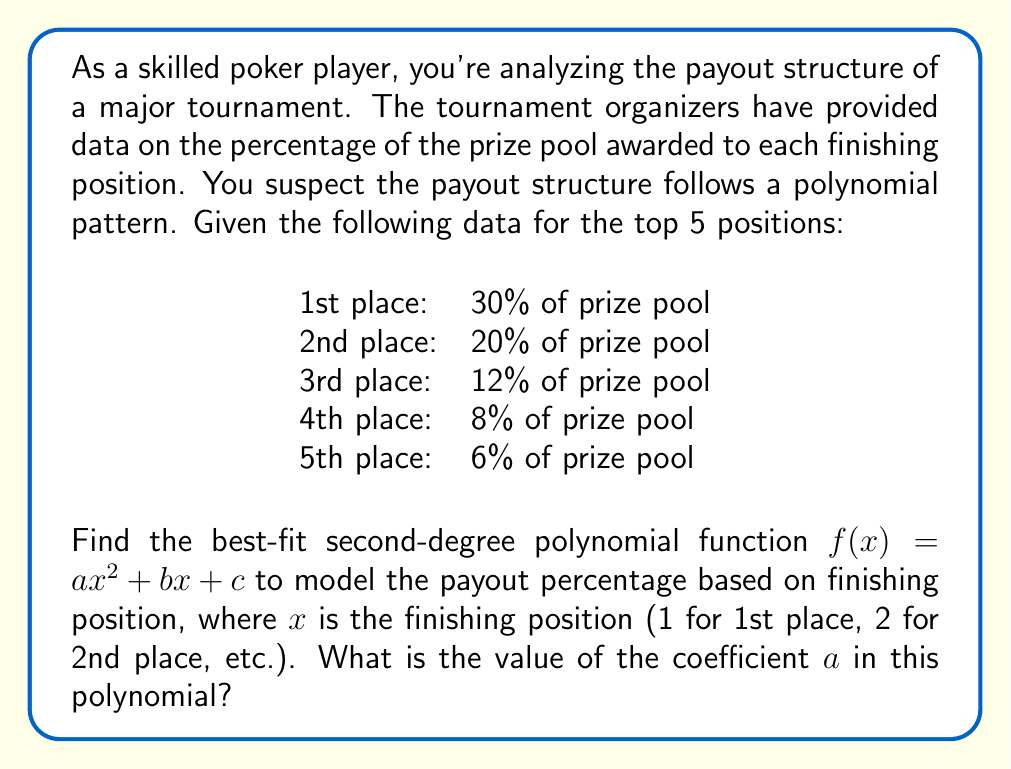Provide a solution to this math problem. To find the best-fit second-degree polynomial, we'll use polynomial regression. Here's the step-by-step process:

1) First, let's set up our data points:
   $(1, 30)$, $(2, 20)$, $(3, 12)$, $(4, 8)$, $(5, 6)$

2) We want to find $f(x) = ax^2 + bx + c$ that best fits these points.

3) To do this, we'll use the normal equations for quadratic regression:

   $$\sum y = an + b\sum x + c\sum x^2$$
   $$\sum xy = a\sum x + b\sum x^2 + c\sum x^3$$
   $$\sum x^2y = a\sum x^2 + b\sum x^3 + c\sum x^4$$

4) Let's calculate the necessary sums:
   $n = 5$
   $\sum x = 1 + 2 + 3 + 4 + 5 = 15$
   $\sum x^2 = 1 + 4 + 9 + 16 + 25 = 55$
   $\sum x^3 = 1 + 8 + 27 + 64 + 125 = 225$
   $\sum x^4 = 1 + 16 + 81 + 256 + 625 = 979$
   $\sum y = 30 + 20 + 12 + 8 + 6 = 76$
   $\sum xy = 30 + 40 + 36 + 32 + 30 = 168$
   $\sum x^2y = 30 + 80 + 108 + 128 + 150 = 496$

5) Substituting these values into our normal equations:

   $76 = 5a + 15b + 55c$
   $168 = 15a + 55b + 225c$
   $496 = 55a + 225b + 979c$

6) Solving this system of equations (you can use a calculator or computer algebra system for this step), we get:

   $a = 2.5$
   $b = -19.9$
   $c = 47.4$

7) Therefore, our best-fit polynomial is:

   $f(x) = 2.5x^2 - 19.9x + 47.4$

The question asks for the value of coefficient $a$, which is 2.5.
Answer: $2.5$ 